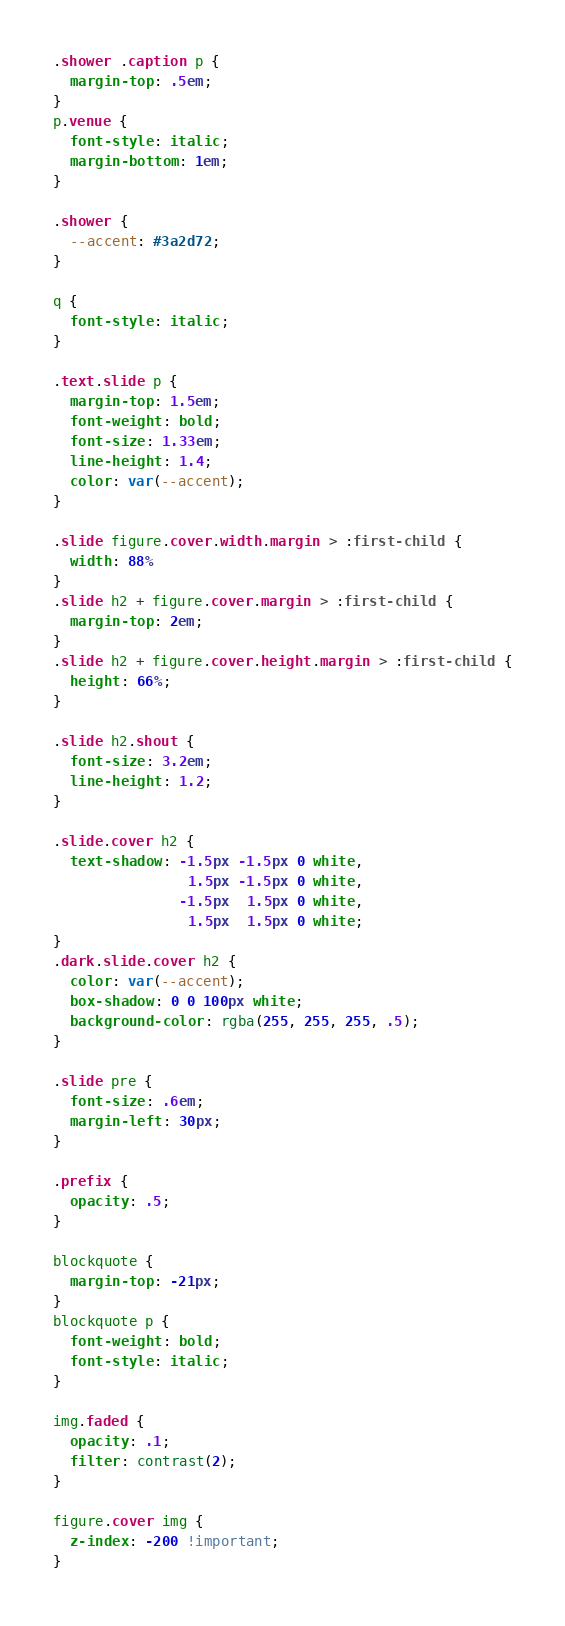Convert code to text. <code><loc_0><loc_0><loc_500><loc_500><_CSS_>.shower .caption p {
  margin-top: .5em;
}
p.venue {
  font-style: italic;
  margin-bottom: 1em;
}

.shower {
  --accent: #3a2d72;
}

q {
  font-style: italic;
}

.text.slide p {
  margin-top: 1.5em;
  font-weight: bold;
  font-size: 1.33em;
  line-height: 1.4;
  color: var(--accent);
}

.slide figure.cover.width.margin > :first-child {
  width: 88%
}
.slide h2 + figure.cover.margin > :first-child {
  margin-top: 2em;
}
.slide h2 + figure.cover.height.margin > :first-child {
  height: 66%;
}

.slide h2.shout {
  font-size: 3.2em;
  line-height: 1.2;
}

.slide.cover h2 {
  text-shadow: -1.5px -1.5px 0 white,
                1.5px -1.5px 0 white,
               -1.5px  1.5px 0 white,
                1.5px  1.5px 0 white;
}
.dark.slide.cover h2 {
  color: var(--accent);
  box-shadow: 0 0 100px white;
  background-color: rgba(255, 255, 255, .5);
}

.slide pre {
  font-size: .6em;
  margin-left: 30px;
}

.prefix {
  opacity: .5;
}

blockquote {
  margin-top: -21px;
}
blockquote p {
  font-weight: bold;
  font-style: italic;
}

img.faded {
  opacity: .1;
  filter: contrast(2);
}

figure.cover img {
  z-index: -200 !important;
}
</code> 